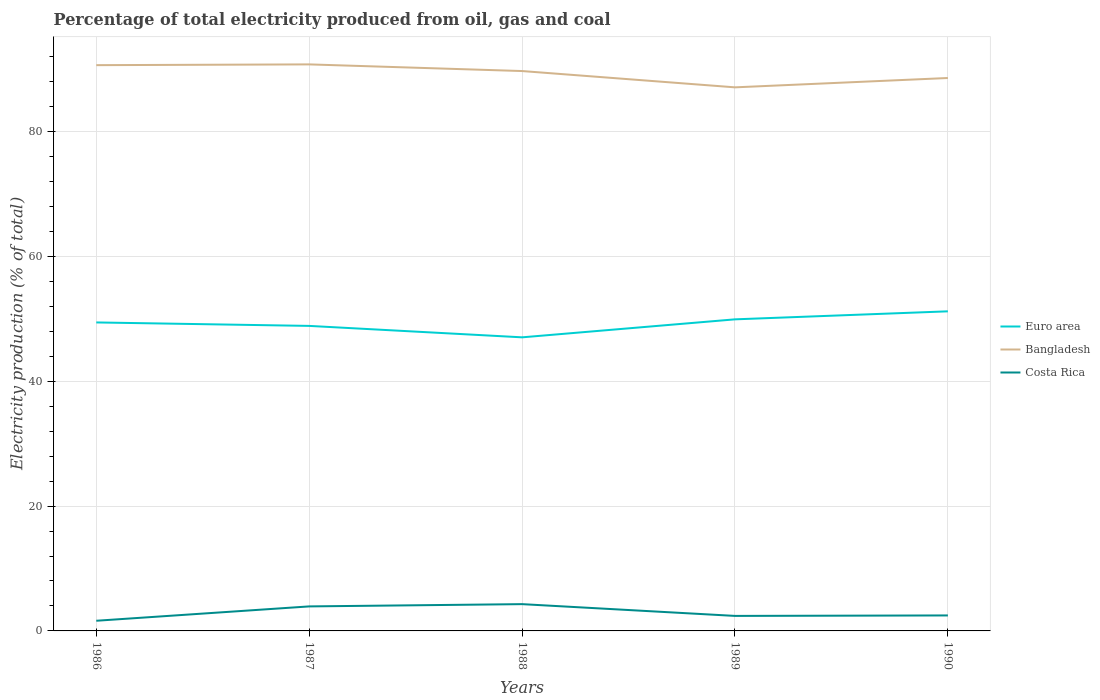Is the number of lines equal to the number of legend labels?
Give a very brief answer. Yes. Across all years, what is the maximum electricity production in in Costa Rica?
Your answer should be compact. 1.63. In which year was the electricity production in in Euro area maximum?
Your answer should be compact. 1988. What is the total electricity production in in Bangladesh in the graph?
Make the answer very short. 3.56. What is the difference between the highest and the second highest electricity production in in Costa Rica?
Offer a very short reply. 2.66. What is the difference between the highest and the lowest electricity production in in Euro area?
Offer a terse response. 3. Is the electricity production in in Euro area strictly greater than the electricity production in in Bangladesh over the years?
Your answer should be very brief. Yes. How many lines are there?
Ensure brevity in your answer.  3. How many years are there in the graph?
Your response must be concise. 5. Are the values on the major ticks of Y-axis written in scientific E-notation?
Your response must be concise. No. Does the graph contain any zero values?
Your response must be concise. No. Does the graph contain grids?
Offer a terse response. Yes. How many legend labels are there?
Offer a very short reply. 3. How are the legend labels stacked?
Your answer should be compact. Vertical. What is the title of the graph?
Provide a succinct answer. Percentage of total electricity produced from oil, gas and coal. What is the label or title of the Y-axis?
Keep it short and to the point. Electricity production (% of total). What is the Electricity production (% of total) in Euro area in 1986?
Provide a short and direct response. 49.41. What is the Electricity production (% of total) in Bangladesh in 1986?
Offer a very short reply. 90.62. What is the Electricity production (% of total) of Costa Rica in 1986?
Keep it short and to the point. 1.63. What is the Electricity production (% of total) of Euro area in 1987?
Your answer should be compact. 48.86. What is the Electricity production (% of total) of Bangladesh in 1987?
Offer a very short reply. 90.75. What is the Electricity production (% of total) in Costa Rica in 1987?
Provide a short and direct response. 3.93. What is the Electricity production (% of total) of Euro area in 1988?
Give a very brief answer. 47.03. What is the Electricity production (% of total) of Bangladesh in 1988?
Make the answer very short. 89.68. What is the Electricity production (% of total) of Costa Rica in 1988?
Offer a terse response. 4.29. What is the Electricity production (% of total) of Euro area in 1989?
Ensure brevity in your answer.  49.91. What is the Electricity production (% of total) in Bangladesh in 1989?
Your response must be concise. 87.07. What is the Electricity production (% of total) of Costa Rica in 1989?
Offer a terse response. 2.4. What is the Electricity production (% of total) of Euro area in 1990?
Provide a short and direct response. 51.19. What is the Electricity production (% of total) of Bangladesh in 1990?
Your response must be concise. 88.57. What is the Electricity production (% of total) of Costa Rica in 1990?
Provide a short and direct response. 2.48. Across all years, what is the maximum Electricity production (% of total) of Euro area?
Give a very brief answer. 51.19. Across all years, what is the maximum Electricity production (% of total) of Bangladesh?
Your response must be concise. 90.75. Across all years, what is the maximum Electricity production (% of total) in Costa Rica?
Ensure brevity in your answer.  4.29. Across all years, what is the minimum Electricity production (% of total) of Euro area?
Offer a very short reply. 47.03. Across all years, what is the minimum Electricity production (% of total) in Bangladesh?
Make the answer very short. 87.07. Across all years, what is the minimum Electricity production (% of total) of Costa Rica?
Give a very brief answer. 1.63. What is the total Electricity production (% of total) of Euro area in the graph?
Offer a terse response. 246.4. What is the total Electricity production (% of total) in Bangladesh in the graph?
Make the answer very short. 446.69. What is the total Electricity production (% of total) in Costa Rica in the graph?
Give a very brief answer. 14.73. What is the difference between the Electricity production (% of total) of Euro area in 1986 and that in 1987?
Keep it short and to the point. 0.55. What is the difference between the Electricity production (% of total) of Bangladesh in 1986 and that in 1987?
Offer a very short reply. -0.12. What is the difference between the Electricity production (% of total) of Costa Rica in 1986 and that in 1987?
Ensure brevity in your answer.  -2.3. What is the difference between the Electricity production (% of total) in Euro area in 1986 and that in 1988?
Give a very brief answer. 2.39. What is the difference between the Electricity production (% of total) of Bangladesh in 1986 and that in 1988?
Offer a very short reply. 0.94. What is the difference between the Electricity production (% of total) in Costa Rica in 1986 and that in 1988?
Your answer should be compact. -2.66. What is the difference between the Electricity production (% of total) in Euro area in 1986 and that in 1989?
Provide a short and direct response. -0.5. What is the difference between the Electricity production (% of total) of Bangladesh in 1986 and that in 1989?
Your answer should be very brief. 3.56. What is the difference between the Electricity production (% of total) in Costa Rica in 1986 and that in 1989?
Give a very brief answer. -0.78. What is the difference between the Electricity production (% of total) in Euro area in 1986 and that in 1990?
Ensure brevity in your answer.  -1.78. What is the difference between the Electricity production (% of total) in Bangladesh in 1986 and that in 1990?
Your answer should be very brief. 2.06. What is the difference between the Electricity production (% of total) in Costa Rica in 1986 and that in 1990?
Provide a succinct answer. -0.85. What is the difference between the Electricity production (% of total) in Euro area in 1987 and that in 1988?
Ensure brevity in your answer.  1.83. What is the difference between the Electricity production (% of total) of Bangladesh in 1987 and that in 1988?
Offer a very short reply. 1.07. What is the difference between the Electricity production (% of total) of Costa Rica in 1987 and that in 1988?
Provide a short and direct response. -0.36. What is the difference between the Electricity production (% of total) of Euro area in 1987 and that in 1989?
Keep it short and to the point. -1.05. What is the difference between the Electricity production (% of total) of Bangladesh in 1987 and that in 1989?
Your answer should be very brief. 3.68. What is the difference between the Electricity production (% of total) of Costa Rica in 1987 and that in 1989?
Keep it short and to the point. 1.52. What is the difference between the Electricity production (% of total) of Euro area in 1987 and that in 1990?
Your response must be concise. -2.33. What is the difference between the Electricity production (% of total) of Bangladesh in 1987 and that in 1990?
Provide a short and direct response. 2.18. What is the difference between the Electricity production (% of total) of Costa Rica in 1987 and that in 1990?
Offer a terse response. 1.45. What is the difference between the Electricity production (% of total) in Euro area in 1988 and that in 1989?
Keep it short and to the point. -2.88. What is the difference between the Electricity production (% of total) of Bangladesh in 1988 and that in 1989?
Give a very brief answer. 2.61. What is the difference between the Electricity production (% of total) in Costa Rica in 1988 and that in 1989?
Provide a short and direct response. 1.89. What is the difference between the Electricity production (% of total) in Euro area in 1988 and that in 1990?
Offer a very short reply. -4.17. What is the difference between the Electricity production (% of total) of Bangladesh in 1988 and that in 1990?
Make the answer very short. 1.11. What is the difference between the Electricity production (% of total) of Costa Rica in 1988 and that in 1990?
Make the answer very short. 1.81. What is the difference between the Electricity production (% of total) of Euro area in 1989 and that in 1990?
Offer a terse response. -1.28. What is the difference between the Electricity production (% of total) in Bangladesh in 1989 and that in 1990?
Make the answer very short. -1.5. What is the difference between the Electricity production (% of total) in Costa Rica in 1989 and that in 1990?
Keep it short and to the point. -0.08. What is the difference between the Electricity production (% of total) in Euro area in 1986 and the Electricity production (% of total) in Bangladesh in 1987?
Your answer should be compact. -41.33. What is the difference between the Electricity production (% of total) of Euro area in 1986 and the Electricity production (% of total) of Costa Rica in 1987?
Offer a very short reply. 45.49. What is the difference between the Electricity production (% of total) in Bangladesh in 1986 and the Electricity production (% of total) in Costa Rica in 1987?
Your answer should be compact. 86.7. What is the difference between the Electricity production (% of total) of Euro area in 1986 and the Electricity production (% of total) of Bangladesh in 1988?
Your answer should be compact. -40.27. What is the difference between the Electricity production (% of total) in Euro area in 1986 and the Electricity production (% of total) in Costa Rica in 1988?
Give a very brief answer. 45.12. What is the difference between the Electricity production (% of total) in Bangladesh in 1986 and the Electricity production (% of total) in Costa Rica in 1988?
Give a very brief answer. 86.33. What is the difference between the Electricity production (% of total) in Euro area in 1986 and the Electricity production (% of total) in Bangladesh in 1989?
Provide a succinct answer. -37.66. What is the difference between the Electricity production (% of total) in Euro area in 1986 and the Electricity production (% of total) in Costa Rica in 1989?
Keep it short and to the point. 47.01. What is the difference between the Electricity production (% of total) in Bangladesh in 1986 and the Electricity production (% of total) in Costa Rica in 1989?
Keep it short and to the point. 88.22. What is the difference between the Electricity production (% of total) of Euro area in 1986 and the Electricity production (% of total) of Bangladesh in 1990?
Your answer should be very brief. -39.15. What is the difference between the Electricity production (% of total) in Euro area in 1986 and the Electricity production (% of total) in Costa Rica in 1990?
Offer a terse response. 46.93. What is the difference between the Electricity production (% of total) in Bangladesh in 1986 and the Electricity production (% of total) in Costa Rica in 1990?
Ensure brevity in your answer.  88.15. What is the difference between the Electricity production (% of total) in Euro area in 1987 and the Electricity production (% of total) in Bangladesh in 1988?
Ensure brevity in your answer.  -40.82. What is the difference between the Electricity production (% of total) in Euro area in 1987 and the Electricity production (% of total) in Costa Rica in 1988?
Provide a short and direct response. 44.57. What is the difference between the Electricity production (% of total) in Bangladesh in 1987 and the Electricity production (% of total) in Costa Rica in 1988?
Your answer should be compact. 86.46. What is the difference between the Electricity production (% of total) of Euro area in 1987 and the Electricity production (% of total) of Bangladesh in 1989?
Ensure brevity in your answer.  -38.21. What is the difference between the Electricity production (% of total) of Euro area in 1987 and the Electricity production (% of total) of Costa Rica in 1989?
Provide a succinct answer. 46.45. What is the difference between the Electricity production (% of total) in Bangladesh in 1987 and the Electricity production (% of total) in Costa Rica in 1989?
Your answer should be very brief. 88.34. What is the difference between the Electricity production (% of total) of Euro area in 1987 and the Electricity production (% of total) of Bangladesh in 1990?
Your answer should be compact. -39.71. What is the difference between the Electricity production (% of total) in Euro area in 1987 and the Electricity production (% of total) in Costa Rica in 1990?
Give a very brief answer. 46.38. What is the difference between the Electricity production (% of total) of Bangladesh in 1987 and the Electricity production (% of total) of Costa Rica in 1990?
Provide a succinct answer. 88.27. What is the difference between the Electricity production (% of total) of Euro area in 1988 and the Electricity production (% of total) of Bangladesh in 1989?
Provide a succinct answer. -40.04. What is the difference between the Electricity production (% of total) of Euro area in 1988 and the Electricity production (% of total) of Costa Rica in 1989?
Offer a terse response. 44.62. What is the difference between the Electricity production (% of total) of Bangladesh in 1988 and the Electricity production (% of total) of Costa Rica in 1989?
Keep it short and to the point. 87.28. What is the difference between the Electricity production (% of total) of Euro area in 1988 and the Electricity production (% of total) of Bangladesh in 1990?
Provide a succinct answer. -41.54. What is the difference between the Electricity production (% of total) of Euro area in 1988 and the Electricity production (% of total) of Costa Rica in 1990?
Give a very brief answer. 44.55. What is the difference between the Electricity production (% of total) of Bangladesh in 1988 and the Electricity production (% of total) of Costa Rica in 1990?
Your response must be concise. 87.2. What is the difference between the Electricity production (% of total) of Euro area in 1989 and the Electricity production (% of total) of Bangladesh in 1990?
Your answer should be compact. -38.66. What is the difference between the Electricity production (% of total) of Euro area in 1989 and the Electricity production (% of total) of Costa Rica in 1990?
Offer a terse response. 47.43. What is the difference between the Electricity production (% of total) in Bangladesh in 1989 and the Electricity production (% of total) in Costa Rica in 1990?
Your response must be concise. 84.59. What is the average Electricity production (% of total) of Euro area per year?
Ensure brevity in your answer.  49.28. What is the average Electricity production (% of total) in Bangladesh per year?
Ensure brevity in your answer.  89.34. What is the average Electricity production (% of total) of Costa Rica per year?
Make the answer very short. 2.95. In the year 1986, what is the difference between the Electricity production (% of total) in Euro area and Electricity production (% of total) in Bangladesh?
Give a very brief answer. -41.21. In the year 1986, what is the difference between the Electricity production (% of total) in Euro area and Electricity production (% of total) in Costa Rica?
Make the answer very short. 47.78. In the year 1986, what is the difference between the Electricity production (% of total) of Bangladesh and Electricity production (% of total) of Costa Rica?
Ensure brevity in your answer.  89. In the year 1987, what is the difference between the Electricity production (% of total) in Euro area and Electricity production (% of total) in Bangladesh?
Provide a succinct answer. -41.89. In the year 1987, what is the difference between the Electricity production (% of total) in Euro area and Electricity production (% of total) in Costa Rica?
Provide a succinct answer. 44.93. In the year 1987, what is the difference between the Electricity production (% of total) of Bangladesh and Electricity production (% of total) of Costa Rica?
Ensure brevity in your answer.  86.82. In the year 1988, what is the difference between the Electricity production (% of total) in Euro area and Electricity production (% of total) in Bangladesh?
Your answer should be compact. -42.65. In the year 1988, what is the difference between the Electricity production (% of total) of Euro area and Electricity production (% of total) of Costa Rica?
Make the answer very short. 42.74. In the year 1988, what is the difference between the Electricity production (% of total) of Bangladesh and Electricity production (% of total) of Costa Rica?
Your answer should be compact. 85.39. In the year 1989, what is the difference between the Electricity production (% of total) of Euro area and Electricity production (% of total) of Bangladesh?
Your response must be concise. -37.16. In the year 1989, what is the difference between the Electricity production (% of total) of Euro area and Electricity production (% of total) of Costa Rica?
Your response must be concise. 47.5. In the year 1989, what is the difference between the Electricity production (% of total) in Bangladesh and Electricity production (% of total) in Costa Rica?
Offer a very short reply. 84.66. In the year 1990, what is the difference between the Electricity production (% of total) of Euro area and Electricity production (% of total) of Bangladesh?
Your response must be concise. -37.37. In the year 1990, what is the difference between the Electricity production (% of total) in Euro area and Electricity production (% of total) in Costa Rica?
Provide a short and direct response. 48.71. In the year 1990, what is the difference between the Electricity production (% of total) of Bangladesh and Electricity production (% of total) of Costa Rica?
Provide a short and direct response. 86.09. What is the ratio of the Electricity production (% of total) in Euro area in 1986 to that in 1987?
Offer a very short reply. 1.01. What is the ratio of the Electricity production (% of total) in Costa Rica in 1986 to that in 1987?
Provide a succinct answer. 0.41. What is the ratio of the Electricity production (% of total) of Euro area in 1986 to that in 1988?
Make the answer very short. 1.05. What is the ratio of the Electricity production (% of total) of Bangladesh in 1986 to that in 1988?
Give a very brief answer. 1.01. What is the ratio of the Electricity production (% of total) in Costa Rica in 1986 to that in 1988?
Make the answer very short. 0.38. What is the ratio of the Electricity production (% of total) of Bangladesh in 1986 to that in 1989?
Give a very brief answer. 1.04. What is the ratio of the Electricity production (% of total) of Costa Rica in 1986 to that in 1989?
Make the answer very short. 0.68. What is the ratio of the Electricity production (% of total) in Euro area in 1986 to that in 1990?
Ensure brevity in your answer.  0.97. What is the ratio of the Electricity production (% of total) in Bangladesh in 1986 to that in 1990?
Your response must be concise. 1.02. What is the ratio of the Electricity production (% of total) in Costa Rica in 1986 to that in 1990?
Make the answer very short. 0.66. What is the ratio of the Electricity production (% of total) in Euro area in 1987 to that in 1988?
Provide a short and direct response. 1.04. What is the ratio of the Electricity production (% of total) in Bangladesh in 1987 to that in 1988?
Offer a terse response. 1.01. What is the ratio of the Electricity production (% of total) in Costa Rica in 1987 to that in 1988?
Your answer should be compact. 0.92. What is the ratio of the Electricity production (% of total) of Euro area in 1987 to that in 1989?
Your response must be concise. 0.98. What is the ratio of the Electricity production (% of total) in Bangladesh in 1987 to that in 1989?
Provide a succinct answer. 1.04. What is the ratio of the Electricity production (% of total) of Costa Rica in 1987 to that in 1989?
Offer a very short reply. 1.63. What is the ratio of the Electricity production (% of total) in Euro area in 1987 to that in 1990?
Your answer should be very brief. 0.95. What is the ratio of the Electricity production (% of total) of Bangladesh in 1987 to that in 1990?
Offer a terse response. 1.02. What is the ratio of the Electricity production (% of total) of Costa Rica in 1987 to that in 1990?
Make the answer very short. 1.58. What is the ratio of the Electricity production (% of total) in Euro area in 1988 to that in 1989?
Your answer should be very brief. 0.94. What is the ratio of the Electricity production (% of total) of Bangladesh in 1988 to that in 1989?
Ensure brevity in your answer.  1.03. What is the ratio of the Electricity production (% of total) of Costa Rica in 1988 to that in 1989?
Ensure brevity in your answer.  1.78. What is the ratio of the Electricity production (% of total) in Euro area in 1988 to that in 1990?
Offer a very short reply. 0.92. What is the ratio of the Electricity production (% of total) of Bangladesh in 1988 to that in 1990?
Your response must be concise. 1.01. What is the ratio of the Electricity production (% of total) in Costa Rica in 1988 to that in 1990?
Your answer should be very brief. 1.73. What is the ratio of the Electricity production (% of total) in Euro area in 1989 to that in 1990?
Make the answer very short. 0.97. What is the ratio of the Electricity production (% of total) in Bangladesh in 1989 to that in 1990?
Your response must be concise. 0.98. What is the ratio of the Electricity production (% of total) of Costa Rica in 1989 to that in 1990?
Give a very brief answer. 0.97. What is the difference between the highest and the second highest Electricity production (% of total) of Euro area?
Your answer should be compact. 1.28. What is the difference between the highest and the second highest Electricity production (% of total) in Bangladesh?
Offer a very short reply. 0.12. What is the difference between the highest and the second highest Electricity production (% of total) of Costa Rica?
Offer a very short reply. 0.36. What is the difference between the highest and the lowest Electricity production (% of total) of Euro area?
Your response must be concise. 4.17. What is the difference between the highest and the lowest Electricity production (% of total) in Bangladesh?
Make the answer very short. 3.68. What is the difference between the highest and the lowest Electricity production (% of total) in Costa Rica?
Your response must be concise. 2.66. 